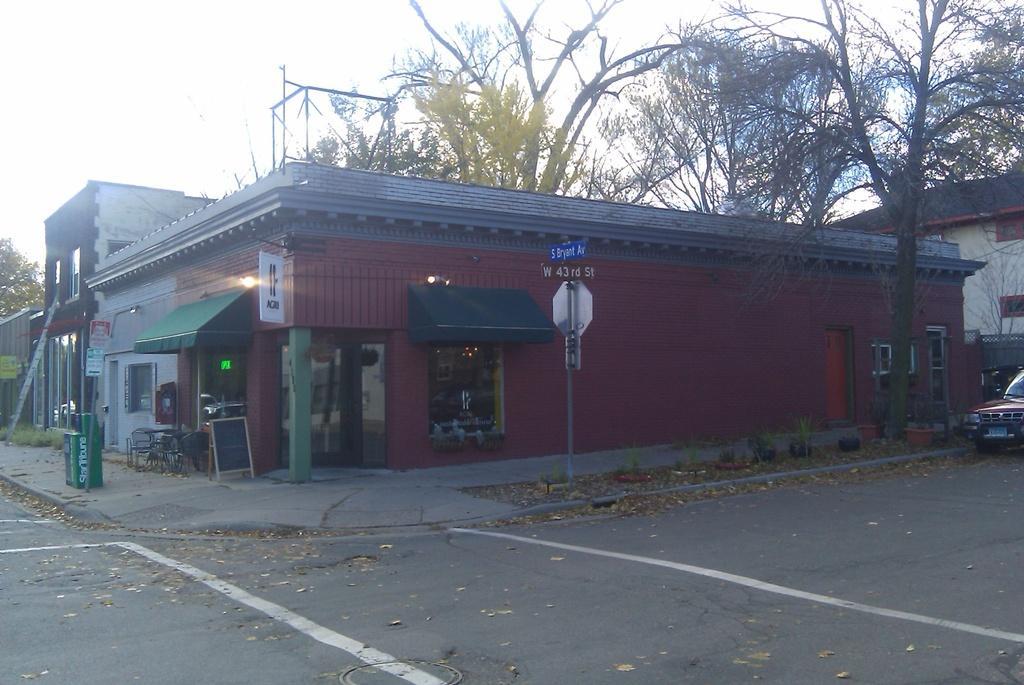In one or two sentences, can you explain what this image depicts? In this image there is a road, on that road there is the car, in the background there is a shop, poles, trees and the sky. 